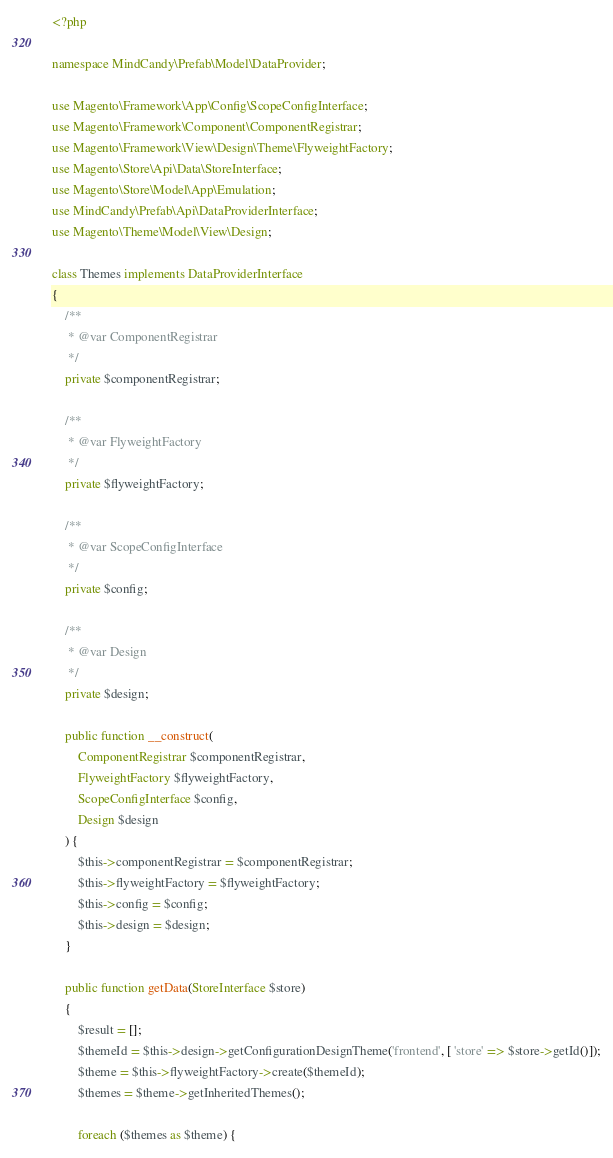Convert code to text. <code><loc_0><loc_0><loc_500><loc_500><_PHP_><?php

namespace MindCandy\Prefab\Model\DataProvider;

use Magento\Framework\App\Config\ScopeConfigInterface;
use Magento\Framework\Component\ComponentRegistrar;
use Magento\Framework\View\Design\Theme\FlyweightFactory;
use Magento\Store\Api\Data\StoreInterface;
use Magento\Store\Model\App\Emulation;
use MindCandy\Prefab\Api\DataProviderInterface;
use Magento\Theme\Model\View\Design;

class Themes implements DataProviderInterface
{
    /**
     * @var ComponentRegistrar
     */
    private $componentRegistrar;

    /**
     * @var FlyweightFactory
     */
    private $flyweightFactory;

    /**
     * @var ScopeConfigInterface
     */
    private $config;

    /**
     * @var Design
     */
    private $design;

    public function __construct(
        ComponentRegistrar $componentRegistrar,
        FlyweightFactory $flyweightFactory,
        ScopeConfigInterface $config,
        Design $design
    ) {
        $this->componentRegistrar = $componentRegistrar;
        $this->flyweightFactory = $flyweightFactory;
        $this->config = $config;
        $this->design = $design;
    }

    public function getData(StoreInterface $store)
    {
        $result = [];
        $themeId = $this->design->getConfigurationDesignTheme('frontend', [ 'store' => $store->getId()]);
        $theme = $this->flyweightFactory->create($themeId);
        $themes = $theme->getInheritedThemes();

        foreach ($themes as $theme) {</code> 